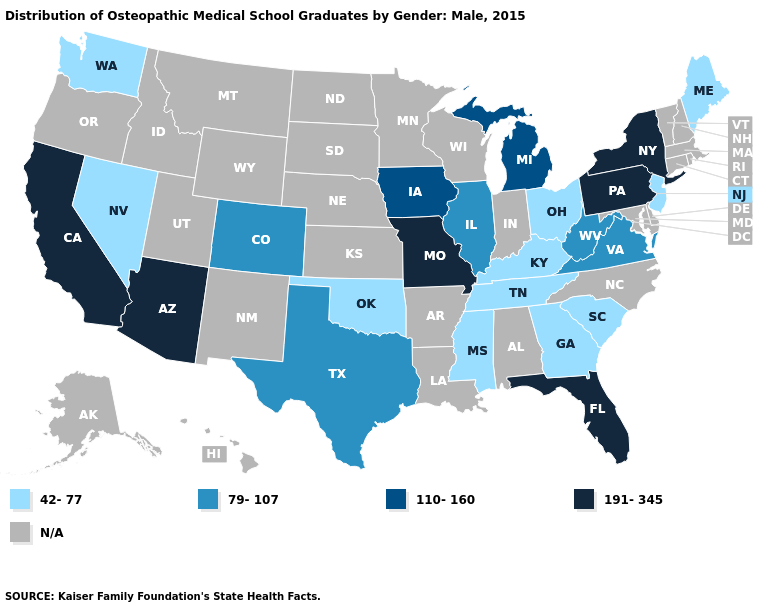Does Ohio have the lowest value in the MidWest?
Keep it brief. Yes. Which states have the highest value in the USA?
Write a very short answer. Arizona, California, Florida, Missouri, New York, Pennsylvania. Name the states that have a value in the range 191-345?
Keep it brief. Arizona, California, Florida, Missouri, New York, Pennsylvania. What is the value of Texas?
Short answer required. 79-107. What is the value of Maryland?
Answer briefly. N/A. What is the lowest value in states that border New Jersey?
Be succinct. 191-345. Which states have the lowest value in the USA?
Concise answer only. Georgia, Kentucky, Maine, Mississippi, Nevada, New Jersey, Ohio, Oklahoma, South Carolina, Tennessee, Washington. How many symbols are there in the legend?
Give a very brief answer. 5. What is the lowest value in states that border New Jersey?
Write a very short answer. 191-345. Name the states that have a value in the range N/A?
Answer briefly. Alabama, Alaska, Arkansas, Connecticut, Delaware, Hawaii, Idaho, Indiana, Kansas, Louisiana, Maryland, Massachusetts, Minnesota, Montana, Nebraska, New Hampshire, New Mexico, North Carolina, North Dakota, Oregon, Rhode Island, South Dakota, Utah, Vermont, Wisconsin, Wyoming. Does the first symbol in the legend represent the smallest category?
Answer briefly. Yes. What is the value of Alabama?
Give a very brief answer. N/A. 